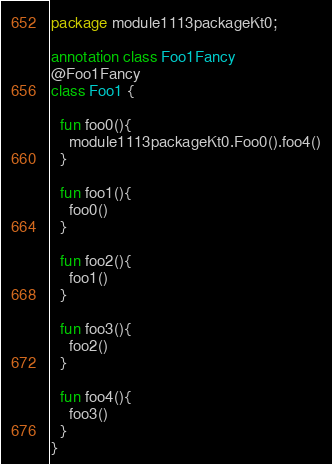Convert code to text. <code><loc_0><loc_0><loc_500><loc_500><_Kotlin_>package module1113packageKt0;

annotation class Foo1Fancy
@Foo1Fancy
class Foo1 {

  fun foo0(){
    module1113packageKt0.Foo0().foo4()
  }

  fun foo1(){
    foo0()
  }

  fun foo2(){
    foo1()
  }

  fun foo3(){
    foo2()
  }

  fun foo4(){
    foo3()
  }
}</code> 